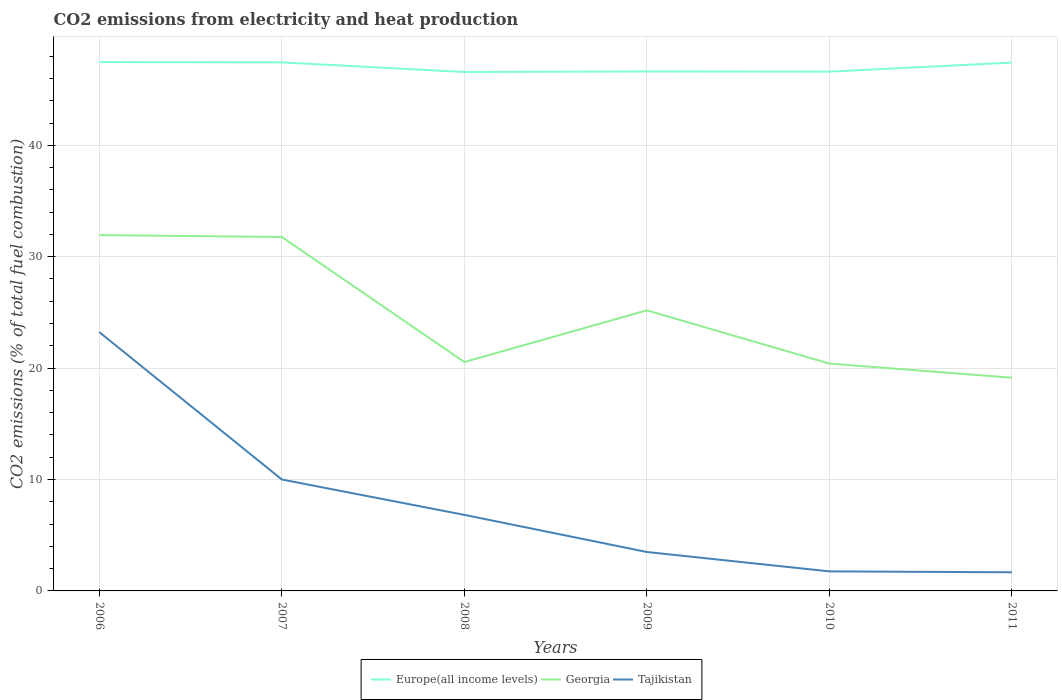How many different coloured lines are there?
Provide a short and direct response. 3. Does the line corresponding to Georgia intersect with the line corresponding to Tajikistan?
Keep it short and to the point. No. Across all years, what is the maximum amount of CO2 emitted in Europe(all income levels)?
Offer a terse response. 46.58. What is the total amount of CO2 emitted in Tajikistan in the graph?
Your answer should be compact. 16.4. What is the difference between the highest and the second highest amount of CO2 emitted in Tajikistan?
Provide a succinct answer. 21.55. Is the amount of CO2 emitted in Europe(all income levels) strictly greater than the amount of CO2 emitted in Georgia over the years?
Offer a very short reply. No. How many years are there in the graph?
Make the answer very short. 6. What is the difference between two consecutive major ticks on the Y-axis?
Give a very brief answer. 10. Are the values on the major ticks of Y-axis written in scientific E-notation?
Provide a short and direct response. No. Does the graph contain any zero values?
Keep it short and to the point. No. Does the graph contain grids?
Ensure brevity in your answer.  Yes. How many legend labels are there?
Your response must be concise. 3. What is the title of the graph?
Offer a terse response. CO2 emissions from electricity and heat production. Does "Tanzania" appear as one of the legend labels in the graph?
Your response must be concise. No. What is the label or title of the Y-axis?
Your answer should be very brief. CO2 emissions (% of total fuel combustion). What is the CO2 emissions (% of total fuel combustion) in Europe(all income levels) in 2006?
Your response must be concise. 47.47. What is the CO2 emissions (% of total fuel combustion) of Georgia in 2006?
Provide a succinct answer. 31.94. What is the CO2 emissions (% of total fuel combustion) of Tajikistan in 2006?
Make the answer very short. 23.23. What is the CO2 emissions (% of total fuel combustion) in Europe(all income levels) in 2007?
Make the answer very short. 47.44. What is the CO2 emissions (% of total fuel combustion) in Georgia in 2007?
Your answer should be very brief. 31.77. What is the CO2 emissions (% of total fuel combustion) in Tajikistan in 2007?
Your answer should be very brief. 10. What is the CO2 emissions (% of total fuel combustion) of Europe(all income levels) in 2008?
Your answer should be compact. 46.58. What is the CO2 emissions (% of total fuel combustion) in Georgia in 2008?
Keep it short and to the point. 20.55. What is the CO2 emissions (% of total fuel combustion) in Tajikistan in 2008?
Give a very brief answer. 6.83. What is the CO2 emissions (% of total fuel combustion) in Europe(all income levels) in 2009?
Offer a terse response. 46.63. What is the CO2 emissions (% of total fuel combustion) in Georgia in 2009?
Keep it short and to the point. 25.19. What is the CO2 emissions (% of total fuel combustion) of Tajikistan in 2009?
Provide a succinct answer. 3.49. What is the CO2 emissions (% of total fuel combustion) in Europe(all income levels) in 2010?
Your response must be concise. 46.61. What is the CO2 emissions (% of total fuel combustion) in Georgia in 2010?
Your response must be concise. 20.41. What is the CO2 emissions (% of total fuel combustion) of Tajikistan in 2010?
Provide a short and direct response. 1.75. What is the CO2 emissions (% of total fuel combustion) in Europe(all income levels) in 2011?
Your answer should be compact. 47.42. What is the CO2 emissions (% of total fuel combustion) in Georgia in 2011?
Provide a succinct answer. 19.14. What is the CO2 emissions (% of total fuel combustion) of Tajikistan in 2011?
Offer a very short reply. 1.67. Across all years, what is the maximum CO2 emissions (% of total fuel combustion) in Europe(all income levels)?
Make the answer very short. 47.47. Across all years, what is the maximum CO2 emissions (% of total fuel combustion) in Georgia?
Give a very brief answer. 31.94. Across all years, what is the maximum CO2 emissions (% of total fuel combustion) of Tajikistan?
Offer a very short reply. 23.23. Across all years, what is the minimum CO2 emissions (% of total fuel combustion) in Europe(all income levels)?
Provide a short and direct response. 46.58. Across all years, what is the minimum CO2 emissions (% of total fuel combustion) of Georgia?
Offer a very short reply. 19.14. Across all years, what is the minimum CO2 emissions (% of total fuel combustion) in Tajikistan?
Ensure brevity in your answer.  1.67. What is the total CO2 emissions (% of total fuel combustion) of Europe(all income levels) in the graph?
Provide a succinct answer. 282.15. What is the total CO2 emissions (% of total fuel combustion) of Georgia in the graph?
Provide a short and direct response. 148.99. What is the total CO2 emissions (% of total fuel combustion) of Tajikistan in the graph?
Your answer should be compact. 46.98. What is the difference between the CO2 emissions (% of total fuel combustion) of Europe(all income levels) in 2006 and that in 2007?
Make the answer very short. 0.03. What is the difference between the CO2 emissions (% of total fuel combustion) of Georgia in 2006 and that in 2007?
Ensure brevity in your answer.  0.17. What is the difference between the CO2 emissions (% of total fuel combustion) in Tajikistan in 2006 and that in 2007?
Offer a terse response. 13.23. What is the difference between the CO2 emissions (% of total fuel combustion) in Europe(all income levels) in 2006 and that in 2008?
Your response must be concise. 0.89. What is the difference between the CO2 emissions (% of total fuel combustion) of Georgia in 2006 and that in 2008?
Make the answer very short. 11.4. What is the difference between the CO2 emissions (% of total fuel combustion) of Tajikistan in 2006 and that in 2008?
Make the answer very short. 16.4. What is the difference between the CO2 emissions (% of total fuel combustion) of Europe(all income levels) in 2006 and that in 2009?
Make the answer very short. 0.84. What is the difference between the CO2 emissions (% of total fuel combustion) in Georgia in 2006 and that in 2009?
Your answer should be compact. 6.75. What is the difference between the CO2 emissions (% of total fuel combustion) of Tajikistan in 2006 and that in 2009?
Ensure brevity in your answer.  19.73. What is the difference between the CO2 emissions (% of total fuel combustion) in Europe(all income levels) in 2006 and that in 2010?
Keep it short and to the point. 0.86. What is the difference between the CO2 emissions (% of total fuel combustion) of Georgia in 2006 and that in 2010?
Keep it short and to the point. 11.53. What is the difference between the CO2 emissions (% of total fuel combustion) in Tajikistan in 2006 and that in 2010?
Provide a short and direct response. 21.47. What is the difference between the CO2 emissions (% of total fuel combustion) of Europe(all income levels) in 2006 and that in 2011?
Offer a very short reply. 0.05. What is the difference between the CO2 emissions (% of total fuel combustion) of Georgia in 2006 and that in 2011?
Provide a short and direct response. 12.8. What is the difference between the CO2 emissions (% of total fuel combustion) of Tajikistan in 2006 and that in 2011?
Offer a very short reply. 21.55. What is the difference between the CO2 emissions (% of total fuel combustion) of Europe(all income levels) in 2007 and that in 2008?
Provide a succinct answer. 0.86. What is the difference between the CO2 emissions (% of total fuel combustion) of Georgia in 2007 and that in 2008?
Make the answer very short. 11.22. What is the difference between the CO2 emissions (% of total fuel combustion) of Tajikistan in 2007 and that in 2008?
Provide a succinct answer. 3.17. What is the difference between the CO2 emissions (% of total fuel combustion) in Europe(all income levels) in 2007 and that in 2009?
Make the answer very short. 0.82. What is the difference between the CO2 emissions (% of total fuel combustion) in Georgia in 2007 and that in 2009?
Your answer should be very brief. 6.58. What is the difference between the CO2 emissions (% of total fuel combustion) of Tajikistan in 2007 and that in 2009?
Ensure brevity in your answer.  6.51. What is the difference between the CO2 emissions (% of total fuel combustion) in Europe(all income levels) in 2007 and that in 2010?
Offer a terse response. 0.83. What is the difference between the CO2 emissions (% of total fuel combustion) of Georgia in 2007 and that in 2010?
Provide a succinct answer. 11.36. What is the difference between the CO2 emissions (% of total fuel combustion) in Tajikistan in 2007 and that in 2010?
Provide a succinct answer. 8.25. What is the difference between the CO2 emissions (% of total fuel combustion) of Europe(all income levels) in 2007 and that in 2011?
Make the answer very short. 0.02. What is the difference between the CO2 emissions (% of total fuel combustion) of Georgia in 2007 and that in 2011?
Provide a succinct answer. 12.63. What is the difference between the CO2 emissions (% of total fuel combustion) in Tajikistan in 2007 and that in 2011?
Ensure brevity in your answer.  8.33. What is the difference between the CO2 emissions (% of total fuel combustion) in Europe(all income levels) in 2008 and that in 2009?
Give a very brief answer. -0.05. What is the difference between the CO2 emissions (% of total fuel combustion) of Georgia in 2008 and that in 2009?
Your answer should be very brief. -4.64. What is the difference between the CO2 emissions (% of total fuel combustion) of Tajikistan in 2008 and that in 2009?
Provide a succinct answer. 3.33. What is the difference between the CO2 emissions (% of total fuel combustion) of Europe(all income levels) in 2008 and that in 2010?
Make the answer very short. -0.03. What is the difference between the CO2 emissions (% of total fuel combustion) of Georgia in 2008 and that in 2010?
Offer a terse response. 0.14. What is the difference between the CO2 emissions (% of total fuel combustion) of Tajikistan in 2008 and that in 2010?
Your answer should be compact. 5.07. What is the difference between the CO2 emissions (% of total fuel combustion) in Europe(all income levels) in 2008 and that in 2011?
Provide a short and direct response. -0.85. What is the difference between the CO2 emissions (% of total fuel combustion) in Georgia in 2008 and that in 2011?
Offer a very short reply. 1.41. What is the difference between the CO2 emissions (% of total fuel combustion) in Tajikistan in 2008 and that in 2011?
Provide a short and direct response. 5.15. What is the difference between the CO2 emissions (% of total fuel combustion) in Europe(all income levels) in 2009 and that in 2010?
Offer a very short reply. 0.02. What is the difference between the CO2 emissions (% of total fuel combustion) of Georgia in 2009 and that in 2010?
Make the answer very short. 4.78. What is the difference between the CO2 emissions (% of total fuel combustion) of Tajikistan in 2009 and that in 2010?
Your response must be concise. 1.74. What is the difference between the CO2 emissions (% of total fuel combustion) in Europe(all income levels) in 2009 and that in 2011?
Make the answer very short. -0.8. What is the difference between the CO2 emissions (% of total fuel combustion) of Georgia in 2009 and that in 2011?
Make the answer very short. 6.05. What is the difference between the CO2 emissions (% of total fuel combustion) of Tajikistan in 2009 and that in 2011?
Ensure brevity in your answer.  1.82. What is the difference between the CO2 emissions (% of total fuel combustion) in Europe(all income levels) in 2010 and that in 2011?
Offer a very short reply. -0.81. What is the difference between the CO2 emissions (% of total fuel combustion) in Georgia in 2010 and that in 2011?
Your answer should be very brief. 1.27. What is the difference between the CO2 emissions (% of total fuel combustion) of Tajikistan in 2010 and that in 2011?
Your response must be concise. 0.08. What is the difference between the CO2 emissions (% of total fuel combustion) of Europe(all income levels) in 2006 and the CO2 emissions (% of total fuel combustion) of Georgia in 2007?
Keep it short and to the point. 15.7. What is the difference between the CO2 emissions (% of total fuel combustion) of Europe(all income levels) in 2006 and the CO2 emissions (% of total fuel combustion) of Tajikistan in 2007?
Your answer should be compact. 37.47. What is the difference between the CO2 emissions (% of total fuel combustion) in Georgia in 2006 and the CO2 emissions (% of total fuel combustion) in Tajikistan in 2007?
Your response must be concise. 21.94. What is the difference between the CO2 emissions (% of total fuel combustion) in Europe(all income levels) in 2006 and the CO2 emissions (% of total fuel combustion) in Georgia in 2008?
Give a very brief answer. 26.92. What is the difference between the CO2 emissions (% of total fuel combustion) in Europe(all income levels) in 2006 and the CO2 emissions (% of total fuel combustion) in Tajikistan in 2008?
Your answer should be very brief. 40.64. What is the difference between the CO2 emissions (% of total fuel combustion) of Georgia in 2006 and the CO2 emissions (% of total fuel combustion) of Tajikistan in 2008?
Ensure brevity in your answer.  25.12. What is the difference between the CO2 emissions (% of total fuel combustion) of Europe(all income levels) in 2006 and the CO2 emissions (% of total fuel combustion) of Georgia in 2009?
Your response must be concise. 22.28. What is the difference between the CO2 emissions (% of total fuel combustion) in Europe(all income levels) in 2006 and the CO2 emissions (% of total fuel combustion) in Tajikistan in 2009?
Keep it short and to the point. 43.98. What is the difference between the CO2 emissions (% of total fuel combustion) in Georgia in 2006 and the CO2 emissions (% of total fuel combustion) in Tajikistan in 2009?
Provide a short and direct response. 28.45. What is the difference between the CO2 emissions (% of total fuel combustion) in Europe(all income levels) in 2006 and the CO2 emissions (% of total fuel combustion) in Georgia in 2010?
Make the answer very short. 27.06. What is the difference between the CO2 emissions (% of total fuel combustion) in Europe(all income levels) in 2006 and the CO2 emissions (% of total fuel combustion) in Tajikistan in 2010?
Offer a very short reply. 45.72. What is the difference between the CO2 emissions (% of total fuel combustion) in Georgia in 2006 and the CO2 emissions (% of total fuel combustion) in Tajikistan in 2010?
Provide a short and direct response. 30.19. What is the difference between the CO2 emissions (% of total fuel combustion) in Europe(all income levels) in 2006 and the CO2 emissions (% of total fuel combustion) in Georgia in 2011?
Your response must be concise. 28.33. What is the difference between the CO2 emissions (% of total fuel combustion) of Europe(all income levels) in 2006 and the CO2 emissions (% of total fuel combustion) of Tajikistan in 2011?
Your response must be concise. 45.8. What is the difference between the CO2 emissions (% of total fuel combustion) in Georgia in 2006 and the CO2 emissions (% of total fuel combustion) in Tajikistan in 2011?
Ensure brevity in your answer.  30.27. What is the difference between the CO2 emissions (% of total fuel combustion) of Europe(all income levels) in 2007 and the CO2 emissions (% of total fuel combustion) of Georgia in 2008?
Ensure brevity in your answer.  26.9. What is the difference between the CO2 emissions (% of total fuel combustion) of Europe(all income levels) in 2007 and the CO2 emissions (% of total fuel combustion) of Tajikistan in 2008?
Offer a very short reply. 40.62. What is the difference between the CO2 emissions (% of total fuel combustion) of Georgia in 2007 and the CO2 emissions (% of total fuel combustion) of Tajikistan in 2008?
Your response must be concise. 24.94. What is the difference between the CO2 emissions (% of total fuel combustion) in Europe(all income levels) in 2007 and the CO2 emissions (% of total fuel combustion) in Georgia in 2009?
Make the answer very short. 22.26. What is the difference between the CO2 emissions (% of total fuel combustion) of Europe(all income levels) in 2007 and the CO2 emissions (% of total fuel combustion) of Tajikistan in 2009?
Make the answer very short. 43.95. What is the difference between the CO2 emissions (% of total fuel combustion) in Georgia in 2007 and the CO2 emissions (% of total fuel combustion) in Tajikistan in 2009?
Offer a terse response. 28.28. What is the difference between the CO2 emissions (% of total fuel combustion) in Europe(all income levels) in 2007 and the CO2 emissions (% of total fuel combustion) in Georgia in 2010?
Keep it short and to the point. 27.03. What is the difference between the CO2 emissions (% of total fuel combustion) in Europe(all income levels) in 2007 and the CO2 emissions (% of total fuel combustion) in Tajikistan in 2010?
Offer a very short reply. 45.69. What is the difference between the CO2 emissions (% of total fuel combustion) in Georgia in 2007 and the CO2 emissions (% of total fuel combustion) in Tajikistan in 2010?
Offer a terse response. 30.01. What is the difference between the CO2 emissions (% of total fuel combustion) in Europe(all income levels) in 2007 and the CO2 emissions (% of total fuel combustion) in Georgia in 2011?
Your response must be concise. 28.3. What is the difference between the CO2 emissions (% of total fuel combustion) of Europe(all income levels) in 2007 and the CO2 emissions (% of total fuel combustion) of Tajikistan in 2011?
Provide a short and direct response. 45.77. What is the difference between the CO2 emissions (% of total fuel combustion) of Georgia in 2007 and the CO2 emissions (% of total fuel combustion) of Tajikistan in 2011?
Your answer should be compact. 30.1. What is the difference between the CO2 emissions (% of total fuel combustion) of Europe(all income levels) in 2008 and the CO2 emissions (% of total fuel combustion) of Georgia in 2009?
Your answer should be very brief. 21.39. What is the difference between the CO2 emissions (% of total fuel combustion) in Europe(all income levels) in 2008 and the CO2 emissions (% of total fuel combustion) in Tajikistan in 2009?
Your answer should be compact. 43.08. What is the difference between the CO2 emissions (% of total fuel combustion) in Georgia in 2008 and the CO2 emissions (% of total fuel combustion) in Tajikistan in 2009?
Give a very brief answer. 17.05. What is the difference between the CO2 emissions (% of total fuel combustion) of Europe(all income levels) in 2008 and the CO2 emissions (% of total fuel combustion) of Georgia in 2010?
Your response must be concise. 26.17. What is the difference between the CO2 emissions (% of total fuel combustion) in Europe(all income levels) in 2008 and the CO2 emissions (% of total fuel combustion) in Tajikistan in 2010?
Provide a succinct answer. 44.82. What is the difference between the CO2 emissions (% of total fuel combustion) in Georgia in 2008 and the CO2 emissions (% of total fuel combustion) in Tajikistan in 2010?
Give a very brief answer. 18.79. What is the difference between the CO2 emissions (% of total fuel combustion) in Europe(all income levels) in 2008 and the CO2 emissions (% of total fuel combustion) in Georgia in 2011?
Your answer should be compact. 27.44. What is the difference between the CO2 emissions (% of total fuel combustion) of Europe(all income levels) in 2008 and the CO2 emissions (% of total fuel combustion) of Tajikistan in 2011?
Your answer should be very brief. 44.9. What is the difference between the CO2 emissions (% of total fuel combustion) of Georgia in 2008 and the CO2 emissions (% of total fuel combustion) of Tajikistan in 2011?
Offer a very short reply. 18.87. What is the difference between the CO2 emissions (% of total fuel combustion) in Europe(all income levels) in 2009 and the CO2 emissions (% of total fuel combustion) in Georgia in 2010?
Provide a succinct answer. 26.22. What is the difference between the CO2 emissions (% of total fuel combustion) in Europe(all income levels) in 2009 and the CO2 emissions (% of total fuel combustion) in Tajikistan in 2010?
Your response must be concise. 44.87. What is the difference between the CO2 emissions (% of total fuel combustion) in Georgia in 2009 and the CO2 emissions (% of total fuel combustion) in Tajikistan in 2010?
Provide a short and direct response. 23.43. What is the difference between the CO2 emissions (% of total fuel combustion) of Europe(all income levels) in 2009 and the CO2 emissions (% of total fuel combustion) of Georgia in 2011?
Offer a terse response. 27.49. What is the difference between the CO2 emissions (% of total fuel combustion) of Europe(all income levels) in 2009 and the CO2 emissions (% of total fuel combustion) of Tajikistan in 2011?
Provide a succinct answer. 44.95. What is the difference between the CO2 emissions (% of total fuel combustion) of Georgia in 2009 and the CO2 emissions (% of total fuel combustion) of Tajikistan in 2011?
Your response must be concise. 23.51. What is the difference between the CO2 emissions (% of total fuel combustion) of Europe(all income levels) in 2010 and the CO2 emissions (% of total fuel combustion) of Georgia in 2011?
Make the answer very short. 27.47. What is the difference between the CO2 emissions (% of total fuel combustion) of Europe(all income levels) in 2010 and the CO2 emissions (% of total fuel combustion) of Tajikistan in 2011?
Offer a very short reply. 44.94. What is the difference between the CO2 emissions (% of total fuel combustion) of Georgia in 2010 and the CO2 emissions (% of total fuel combustion) of Tajikistan in 2011?
Give a very brief answer. 18.73. What is the average CO2 emissions (% of total fuel combustion) of Europe(all income levels) per year?
Your answer should be very brief. 47.03. What is the average CO2 emissions (% of total fuel combustion) of Georgia per year?
Provide a short and direct response. 24.83. What is the average CO2 emissions (% of total fuel combustion) in Tajikistan per year?
Provide a short and direct response. 7.83. In the year 2006, what is the difference between the CO2 emissions (% of total fuel combustion) of Europe(all income levels) and CO2 emissions (% of total fuel combustion) of Georgia?
Your answer should be very brief. 15.53. In the year 2006, what is the difference between the CO2 emissions (% of total fuel combustion) in Europe(all income levels) and CO2 emissions (% of total fuel combustion) in Tajikistan?
Ensure brevity in your answer.  24.24. In the year 2006, what is the difference between the CO2 emissions (% of total fuel combustion) in Georgia and CO2 emissions (% of total fuel combustion) in Tajikistan?
Your answer should be compact. 8.71. In the year 2007, what is the difference between the CO2 emissions (% of total fuel combustion) of Europe(all income levels) and CO2 emissions (% of total fuel combustion) of Georgia?
Provide a succinct answer. 15.67. In the year 2007, what is the difference between the CO2 emissions (% of total fuel combustion) of Europe(all income levels) and CO2 emissions (% of total fuel combustion) of Tajikistan?
Ensure brevity in your answer.  37.44. In the year 2007, what is the difference between the CO2 emissions (% of total fuel combustion) of Georgia and CO2 emissions (% of total fuel combustion) of Tajikistan?
Offer a very short reply. 21.77. In the year 2008, what is the difference between the CO2 emissions (% of total fuel combustion) of Europe(all income levels) and CO2 emissions (% of total fuel combustion) of Georgia?
Keep it short and to the point. 26.03. In the year 2008, what is the difference between the CO2 emissions (% of total fuel combustion) in Europe(all income levels) and CO2 emissions (% of total fuel combustion) in Tajikistan?
Give a very brief answer. 39.75. In the year 2008, what is the difference between the CO2 emissions (% of total fuel combustion) in Georgia and CO2 emissions (% of total fuel combustion) in Tajikistan?
Your answer should be very brief. 13.72. In the year 2009, what is the difference between the CO2 emissions (% of total fuel combustion) in Europe(all income levels) and CO2 emissions (% of total fuel combustion) in Georgia?
Provide a short and direct response. 21.44. In the year 2009, what is the difference between the CO2 emissions (% of total fuel combustion) in Europe(all income levels) and CO2 emissions (% of total fuel combustion) in Tajikistan?
Provide a succinct answer. 43.13. In the year 2009, what is the difference between the CO2 emissions (% of total fuel combustion) of Georgia and CO2 emissions (% of total fuel combustion) of Tajikistan?
Your answer should be very brief. 21.69. In the year 2010, what is the difference between the CO2 emissions (% of total fuel combustion) in Europe(all income levels) and CO2 emissions (% of total fuel combustion) in Georgia?
Your answer should be compact. 26.2. In the year 2010, what is the difference between the CO2 emissions (% of total fuel combustion) of Europe(all income levels) and CO2 emissions (% of total fuel combustion) of Tajikistan?
Make the answer very short. 44.86. In the year 2010, what is the difference between the CO2 emissions (% of total fuel combustion) in Georgia and CO2 emissions (% of total fuel combustion) in Tajikistan?
Ensure brevity in your answer.  18.65. In the year 2011, what is the difference between the CO2 emissions (% of total fuel combustion) in Europe(all income levels) and CO2 emissions (% of total fuel combustion) in Georgia?
Your response must be concise. 28.29. In the year 2011, what is the difference between the CO2 emissions (% of total fuel combustion) of Europe(all income levels) and CO2 emissions (% of total fuel combustion) of Tajikistan?
Give a very brief answer. 45.75. In the year 2011, what is the difference between the CO2 emissions (% of total fuel combustion) in Georgia and CO2 emissions (% of total fuel combustion) in Tajikistan?
Provide a succinct answer. 17.47. What is the ratio of the CO2 emissions (% of total fuel combustion) in Europe(all income levels) in 2006 to that in 2007?
Ensure brevity in your answer.  1. What is the ratio of the CO2 emissions (% of total fuel combustion) of Georgia in 2006 to that in 2007?
Ensure brevity in your answer.  1.01. What is the ratio of the CO2 emissions (% of total fuel combustion) of Tajikistan in 2006 to that in 2007?
Your response must be concise. 2.32. What is the ratio of the CO2 emissions (% of total fuel combustion) of Europe(all income levels) in 2006 to that in 2008?
Your answer should be very brief. 1.02. What is the ratio of the CO2 emissions (% of total fuel combustion) of Georgia in 2006 to that in 2008?
Provide a succinct answer. 1.55. What is the ratio of the CO2 emissions (% of total fuel combustion) of Tajikistan in 2006 to that in 2008?
Keep it short and to the point. 3.4. What is the ratio of the CO2 emissions (% of total fuel combustion) in Europe(all income levels) in 2006 to that in 2009?
Give a very brief answer. 1.02. What is the ratio of the CO2 emissions (% of total fuel combustion) in Georgia in 2006 to that in 2009?
Your answer should be very brief. 1.27. What is the ratio of the CO2 emissions (% of total fuel combustion) of Tajikistan in 2006 to that in 2009?
Keep it short and to the point. 6.65. What is the ratio of the CO2 emissions (% of total fuel combustion) in Europe(all income levels) in 2006 to that in 2010?
Provide a succinct answer. 1.02. What is the ratio of the CO2 emissions (% of total fuel combustion) in Georgia in 2006 to that in 2010?
Ensure brevity in your answer.  1.57. What is the ratio of the CO2 emissions (% of total fuel combustion) in Tajikistan in 2006 to that in 2010?
Give a very brief answer. 13.24. What is the ratio of the CO2 emissions (% of total fuel combustion) in Europe(all income levels) in 2006 to that in 2011?
Offer a very short reply. 1. What is the ratio of the CO2 emissions (% of total fuel combustion) in Georgia in 2006 to that in 2011?
Provide a succinct answer. 1.67. What is the ratio of the CO2 emissions (% of total fuel combustion) of Tajikistan in 2006 to that in 2011?
Give a very brief answer. 13.88. What is the ratio of the CO2 emissions (% of total fuel combustion) in Europe(all income levels) in 2007 to that in 2008?
Keep it short and to the point. 1.02. What is the ratio of the CO2 emissions (% of total fuel combustion) in Georgia in 2007 to that in 2008?
Provide a short and direct response. 1.55. What is the ratio of the CO2 emissions (% of total fuel combustion) of Tajikistan in 2007 to that in 2008?
Offer a terse response. 1.47. What is the ratio of the CO2 emissions (% of total fuel combustion) in Europe(all income levels) in 2007 to that in 2009?
Keep it short and to the point. 1.02. What is the ratio of the CO2 emissions (% of total fuel combustion) of Georgia in 2007 to that in 2009?
Your answer should be compact. 1.26. What is the ratio of the CO2 emissions (% of total fuel combustion) of Tajikistan in 2007 to that in 2009?
Offer a very short reply. 2.86. What is the ratio of the CO2 emissions (% of total fuel combustion) of Europe(all income levels) in 2007 to that in 2010?
Offer a very short reply. 1.02. What is the ratio of the CO2 emissions (% of total fuel combustion) in Georgia in 2007 to that in 2010?
Provide a succinct answer. 1.56. What is the ratio of the CO2 emissions (% of total fuel combustion) in Europe(all income levels) in 2007 to that in 2011?
Your answer should be very brief. 1. What is the ratio of the CO2 emissions (% of total fuel combustion) of Georgia in 2007 to that in 2011?
Your answer should be compact. 1.66. What is the ratio of the CO2 emissions (% of total fuel combustion) in Tajikistan in 2007 to that in 2011?
Ensure brevity in your answer.  5.97. What is the ratio of the CO2 emissions (% of total fuel combustion) in Europe(all income levels) in 2008 to that in 2009?
Keep it short and to the point. 1. What is the ratio of the CO2 emissions (% of total fuel combustion) of Georgia in 2008 to that in 2009?
Make the answer very short. 0.82. What is the ratio of the CO2 emissions (% of total fuel combustion) of Tajikistan in 2008 to that in 2009?
Your answer should be compact. 1.95. What is the ratio of the CO2 emissions (% of total fuel combustion) of Europe(all income levels) in 2008 to that in 2010?
Provide a short and direct response. 1. What is the ratio of the CO2 emissions (% of total fuel combustion) of Georgia in 2008 to that in 2010?
Offer a very short reply. 1.01. What is the ratio of the CO2 emissions (% of total fuel combustion) of Tajikistan in 2008 to that in 2010?
Ensure brevity in your answer.  3.89. What is the ratio of the CO2 emissions (% of total fuel combustion) of Europe(all income levels) in 2008 to that in 2011?
Make the answer very short. 0.98. What is the ratio of the CO2 emissions (% of total fuel combustion) in Georgia in 2008 to that in 2011?
Ensure brevity in your answer.  1.07. What is the ratio of the CO2 emissions (% of total fuel combustion) of Tajikistan in 2008 to that in 2011?
Offer a very short reply. 4.08. What is the ratio of the CO2 emissions (% of total fuel combustion) of Europe(all income levels) in 2009 to that in 2010?
Provide a short and direct response. 1. What is the ratio of the CO2 emissions (% of total fuel combustion) of Georgia in 2009 to that in 2010?
Provide a succinct answer. 1.23. What is the ratio of the CO2 emissions (% of total fuel combustion) in Tajikistan in 2009 to that in 2010?
Provide a short and direct response. 1.99. What is the ratio of the CO2 emissions (% of total fuel combustion) of Europe(all income levels) in 2009 to that in 2011?
Your answer should be compact. 0.98. What is the ratio of the CO2 emissions (% of total fuel combustion) in Georgia in 2009 to that in 2011?
Your answer should be very brief. 1.32. What is the ratio of the CO2 emissions (% of total fuel combustion) of Tajikistan in 2009 to that in 2011?
Keep it short and to the point. 2.09. What is the ratio of the CO2 emissions (% of total fuel combustion) in Europe(all income levels) in 2010 to that in 2011?
Your answer should be very brief. 0.98. What is the ratio of the CO2 emissions (% of total fuel combustion) of Georgia in 2010 to that in 2011?
Give a very brief answer. 1.07. What is the ratio of the CO2 emissions (% of total fuel combustion) of Tajikistan in 2010 to that in 2011?
Provide a succinct answer. 1.05. What is the difference between the highest and the second highest CO2 emissions (% of total fuel combustion) in Europe(all income levels)?
Ensure brevity in your answer.  0.03. What is the difference between the highest and the second highest CO2 emissions (% of total fuel combustion) in Georgia?
Ensure brevity in your answer.  0.17. What is the difference between the highest and the second highest CO2 emissions (% of total fuel combustion) in Tajikistan?
Your answer should be very brief. 13.23. What is the difference between the highest and the lowest CO2 emissions (% of total fuel combustion) of Europe(all income levels)?
Your answer should be very brief. 0.89. What is the difference between the highest and the lowest CO2 emissions (% of total fuel combustion) in Georgia?
Your response must be concise. 12.8. What is the difference between the highest and the lowest CO2 emissions (% of total fuel combustion) in Tajikistan?
Provide a succinct answer. 21.55. 